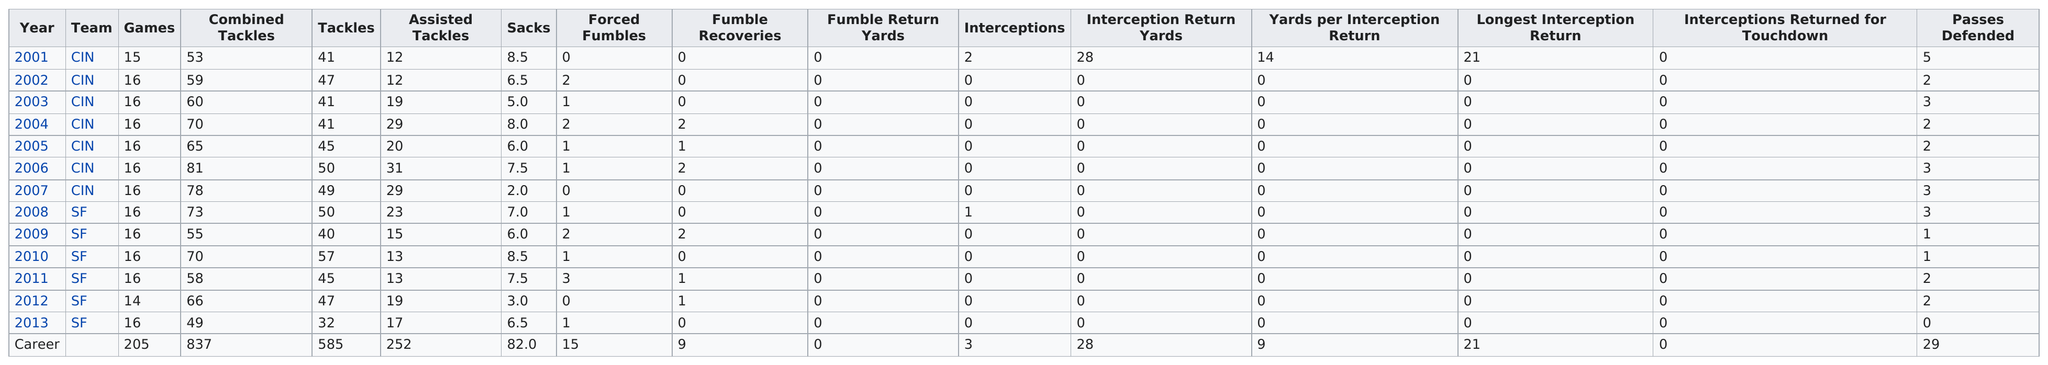Indicate a few pertinent items in this graphic. The first team this player played for was CIN... For how many consecutive seasons has he played at least 16 games? 10... For how many years did he not recover a fumble? 7 years. The total number of sacks that Smith has made is 82. In his illustrious career, this player has averaged a staggering 45 tackles per game, making him one of the most prolific tacklers in the history of the sport. 